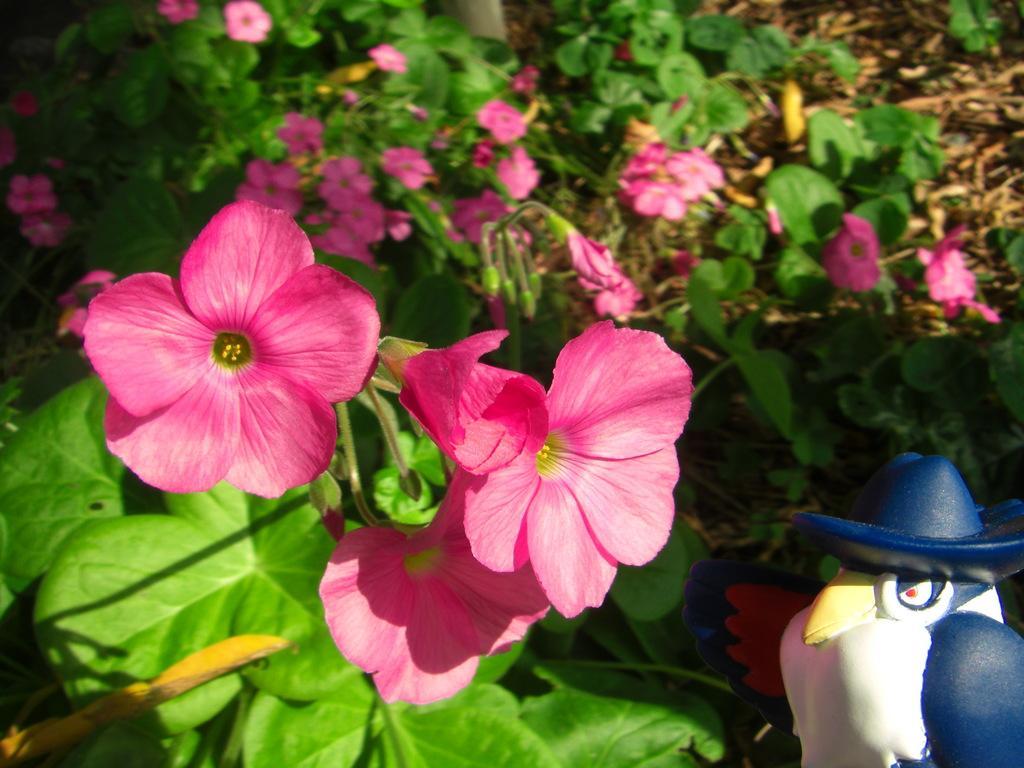How would you summarize this image in a sentence or two? In this image I can see number of pink colour flowers and leaves. On the bottom right side of this image I can see a blue and white colour sculpture. 